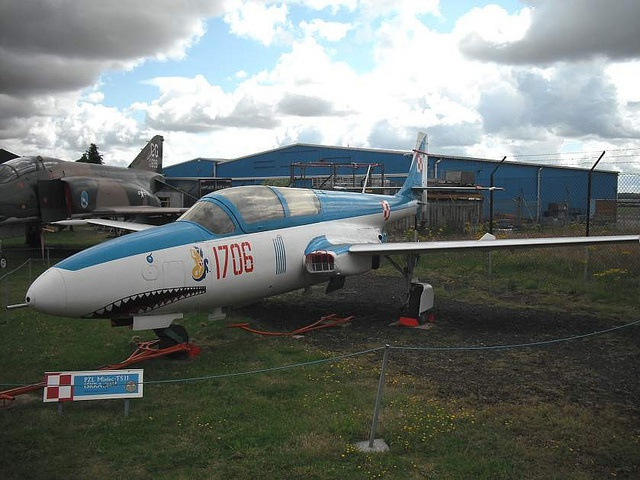Describe the objects in this image and their specific colors. I can see airplane in gray, darkgray, black, and lightgray tones and airplane in gray, black, and darkgray tones in this image. 